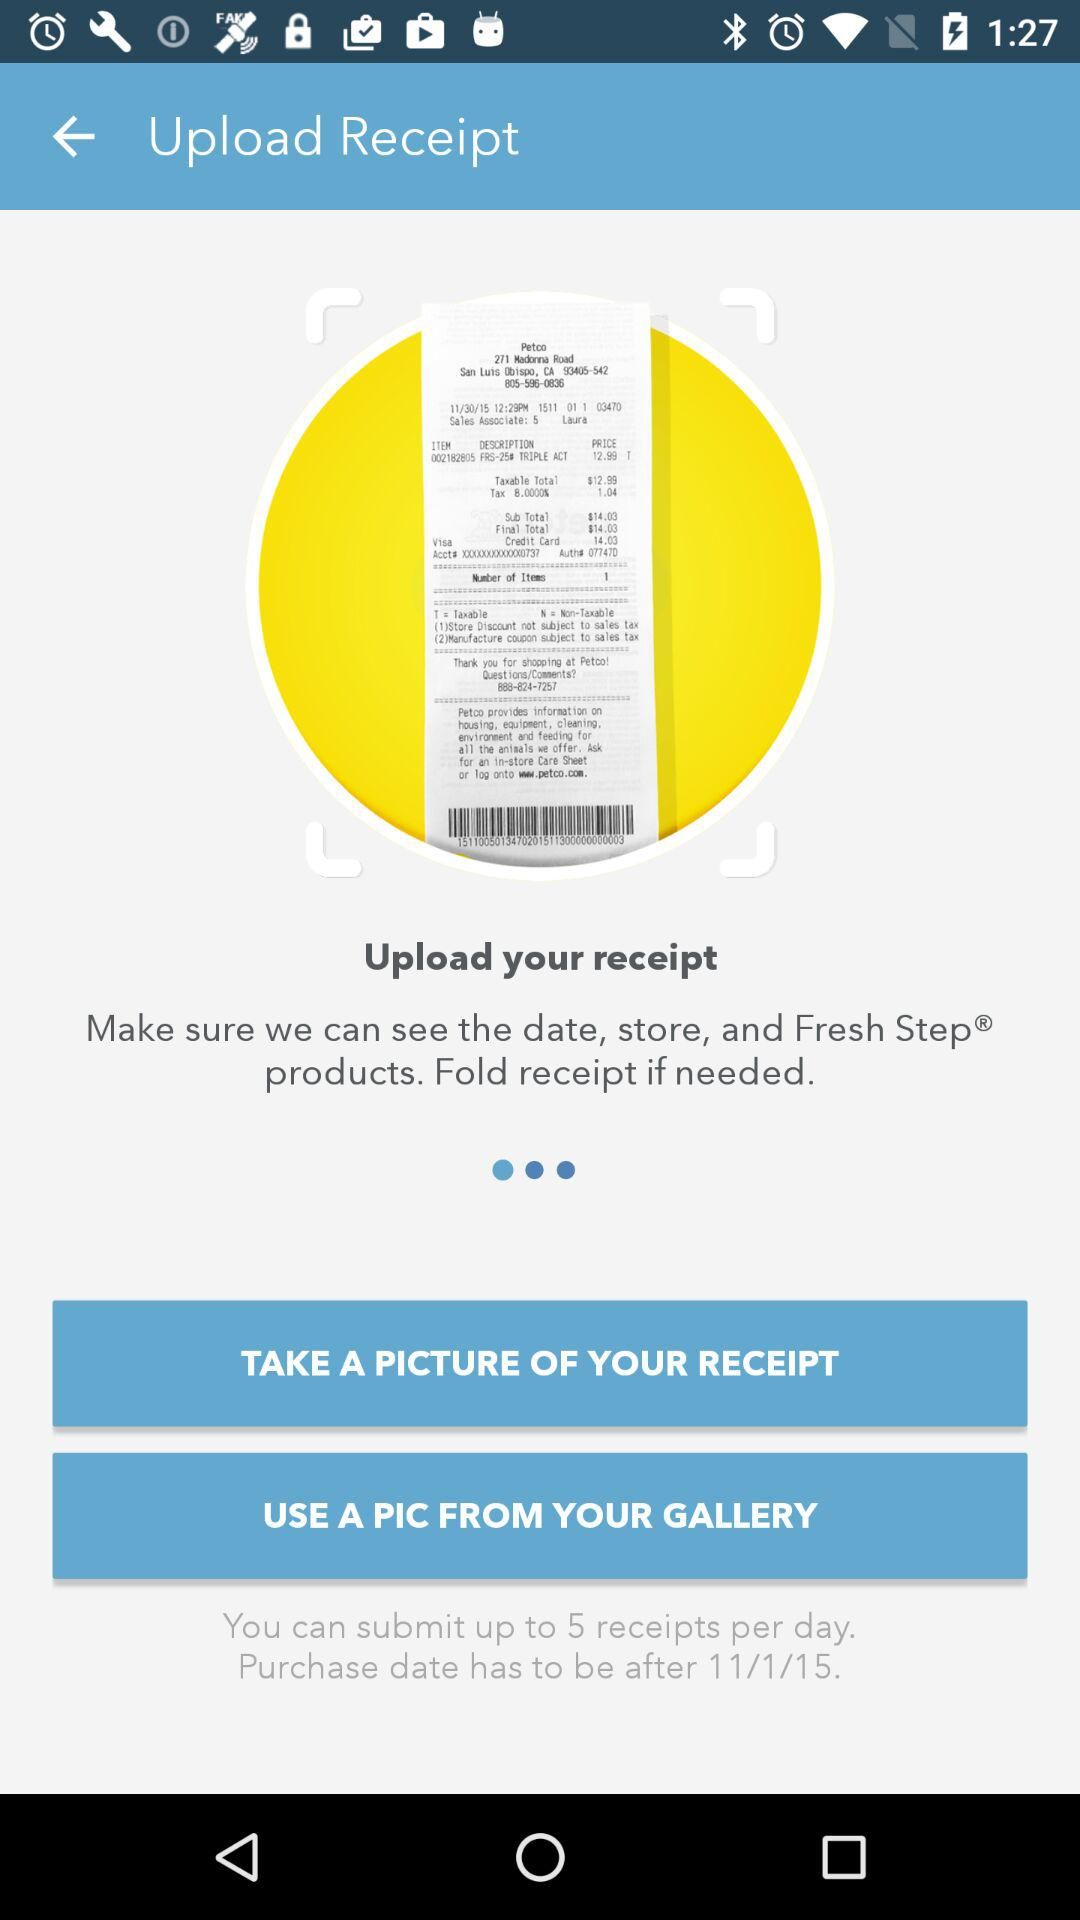On what date was the receipt uploaded?
When the provided information is insufficient, respond with <no answer>. <no answer> 